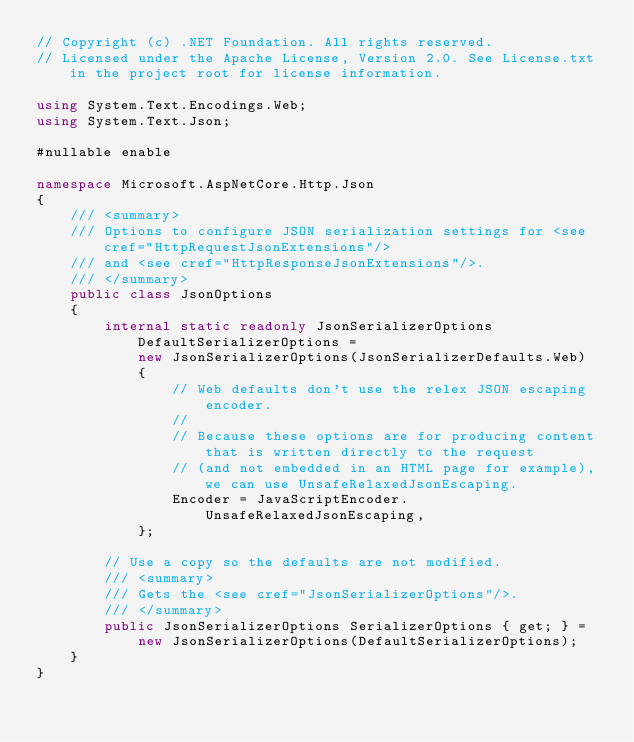<code> <loc_0><loc_0><loc_500><loc_500><_C#_>// Copyright (c) .NET Foundation. All rights reserved.
// Licensed under the Apache License, Version 2.0. See License.txt in the project root for license information.

using System.Text.Encodings.Web;
using System.Text.Json;

#nullable enable

namespace Microsoft.AspNetCore.Http.Json
{
    /// <summary>
    /// Options to configure JSON serialization settings for <see cref="HttpRequestJsonExtensions"/>
    /// and <see cref="HttpResponseJsonExtensions"/>.
    /// </summary>
    public class JsonOptions
    {
        internal static readonly JsonSerializerOptions DefaultSerializerOptions =
            new JsonSerializerOptions(JsonSerializerDefaults.Web)
            {
                // Web defaults don't use the relex JSON escaping encoder.
                //
                // Because these options are for producing content that is written directly to the request
                // (and not embedded in an HTML page for example), we can use UnsafeRelaxedJsonEscaping.
                Encoder = JavaScriptEncoder.UnsafeRelaxedJsonEscaping,
            };

        // Use a copy so the defaults are not modified.
        /// <summary>
        /// Gets the <see cref="JsonSerializerOptions"/>.
        /// </summary>
        public JsonSerializerOptions SerializerOptions { get; } =
            new JsonSerializerOptions(DefaultSerializerOptions);
    }
}
</code> 